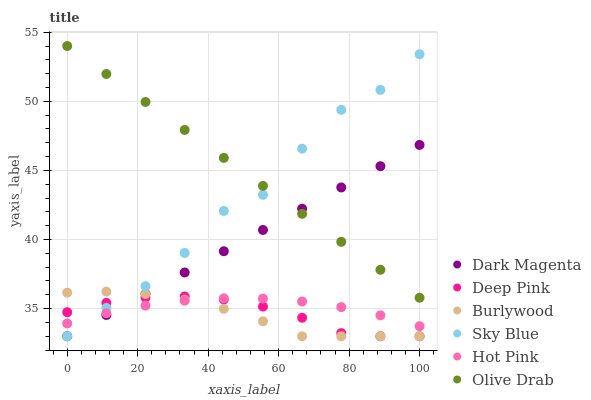Does Burlywood have the minimum area under the curve?
Answer yes or no. Yes. Does Olive Drab have the maximum area under the curve?
Answer yes or no. Yes. Does Dark Magenta have the minimum area under the curve?
Answer yes or no. No. Does Dark Magenta have the maximum area under the curve?
Answer yes or no. No. Is Olive Drab the smoothest?
Answer yes or no. Yes. Is Sky Blue the roughest?
Answer yes or no. Yes. Is Dark Magenta the smoothest?
Answer yes or no. No. Is Dark Magenta the roughest?
Answer yes or no. No. Does Deep Pink have the lowest value?
Answer yes or no. Yes. Does Hot Pink have the lowest value?
Answer yes or no. No. Does Olive Drab have the highest value?
Answer yes or no. Yes. Does Dark Magenta have the highest value?
Answer yes or no. No. Is Burlywood less than Olive Drab?
Answer yes or no. Yes. Is Olive Drab greater than Hot Pink?
Answer yes or no. Yes. Does Sky Blue intersect Burlywood?
Answer yes or no. Yes. Is Sky Blue less than Burlywood?
Answer yes or no. No. Is Sky Blue greater than Burlywood?
Answer yes or no. No. Does Burlywood intersect Olive Drab?
Answer yes or no. No. 